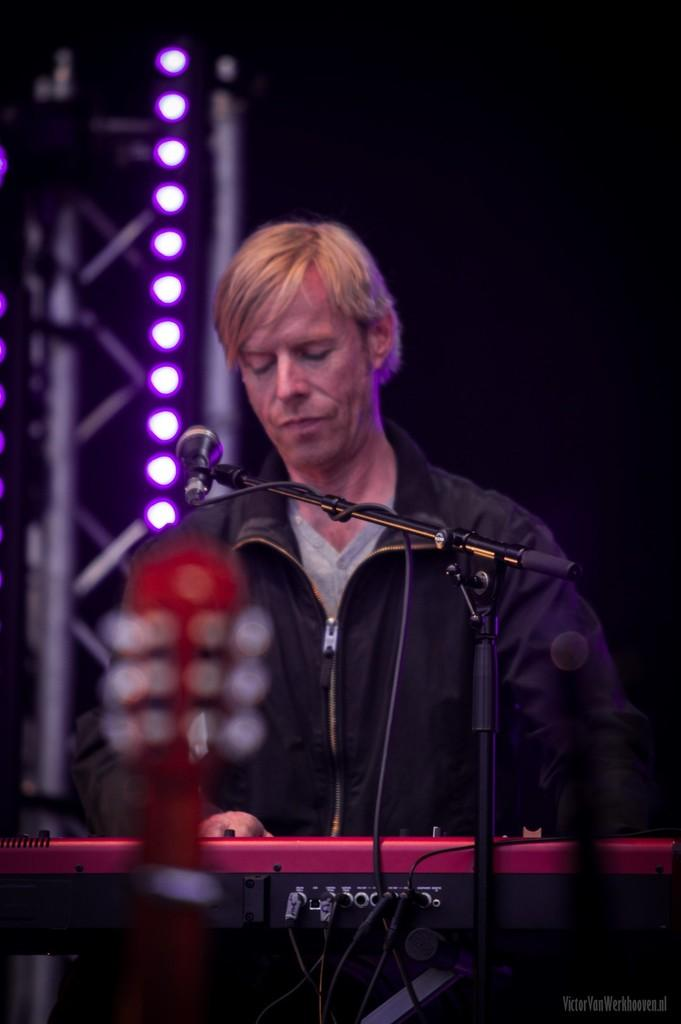What is the person in the image doing? The person in the image is playing a musical instrument. What is the person using to amplify their voice or sound? There is a microphone in front of the person. What can be seen in the background of the image? There are lights visible in the background of the image. How many dimes can be seen on the person's instrument in the image? There are no dimes visible on the person's instrument in the image. What type of creature is playing the musical instrument in the image? The image features a person playing the musical instrument, not a creature. 